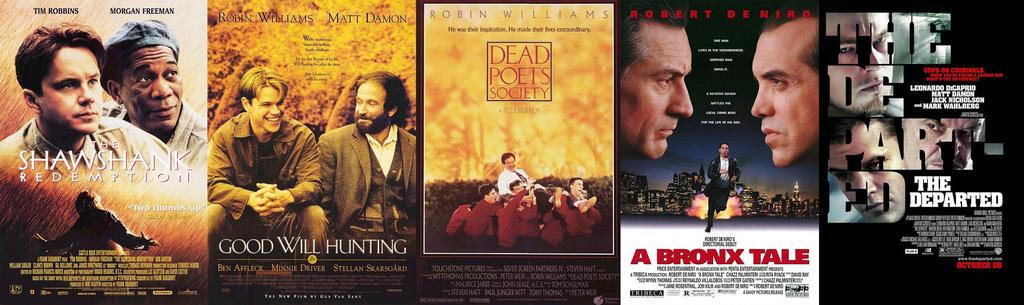What can be seen on the posts in the image? There are posters on the posts in the image. What do the posters contain? The posters contain images of people and some information. Are there any flowers growing on the posts in the image? There are no flowers growing on the posts in the image. Can you tell me how many slaves are depicted on the posters? There is no mention of slaves in the image; the posters contain images of people, but their status or occupation is not specified. 